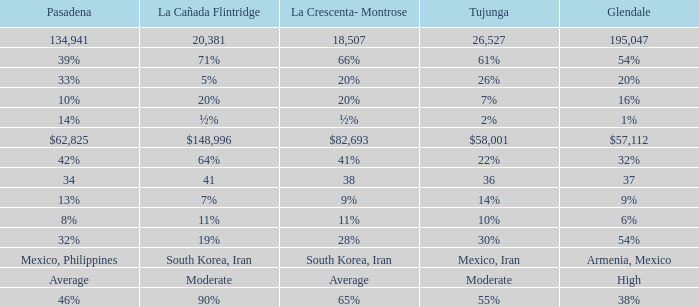What is the figure for Tujunga when Pasadena is 134,941? 26527.0. 